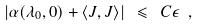<formula> <loc_0><loc_0><loc_500><loc_500>\left | \alpha ( \lambda _ { 0 } , 0 ) + \langle J , J \rangle \right | \ \leqslant \ C \epsilon \ ,</formula> 